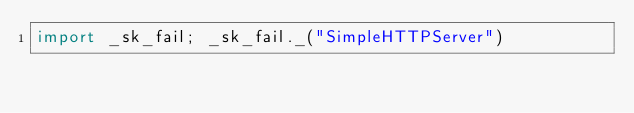Convert code to text. <code><loc_0><loc_0><loc_500><loc_500><_Python_>import _sk_fail; _sk_fail._("SimpleHTTPServer")
</code> 